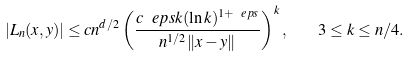Convert formula to latex. <formula><loc_0><loc_0><loc_500><loc_500>| L _ { n } ( x , y ) | \leq c n ^ { d / 2 } \left ( \frac { c _ { \ } e p s k ( \ln k ) ^ { 1 + \ e p s } } { n ^ { 1 / 2 } \| x - y \| } \right ) ^ { k } , \quad 3 \leq k \leq n / 4 .</formula> 